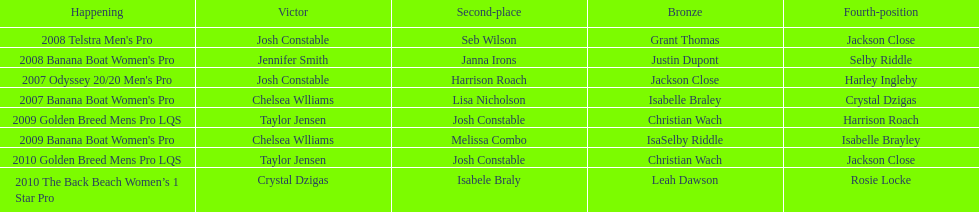Who was the top performer in the 2008 telstra men's pro? Josh Constable. 